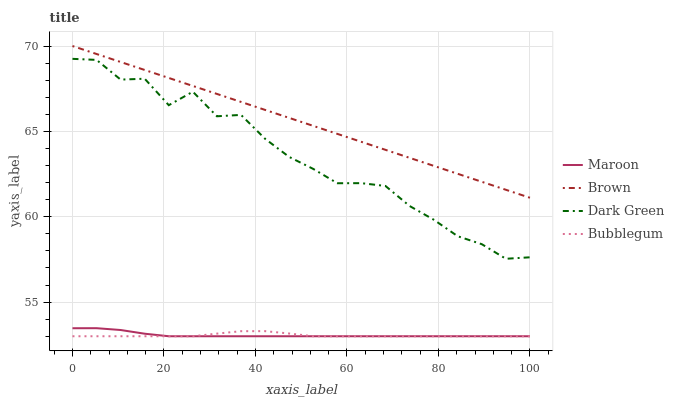Does Maroon have the minimum area under the curve?
Answer yes or no. No. Does Maroon have the maximum area under the curve?
Answer yes or no. No. Is Bubblegum the smoothest?
Answer yes or no. No. Is Bubblegum the roughest?
Answer yes or no. No. Does Dark Green have the lowest value?
Answer yes or no. No. Does Maroon have the highest value?
Answer yes or no. No. Is Dark Green less than Brown?
Answer yes or no. Yes. Is Brown greater than Bubblegum?
Answer yes or no. Yes. Does Dark Green intersect Brown?
Answer yes or no. No. 